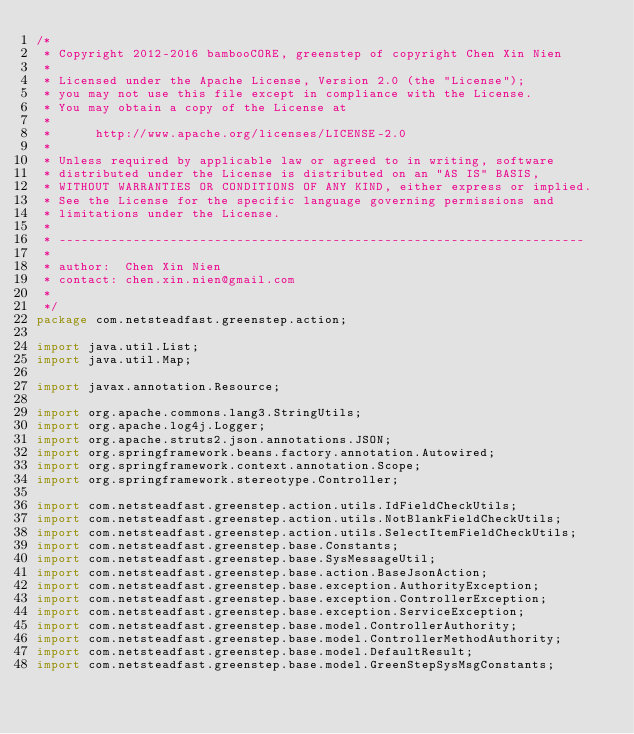<code> <loc_0><loc_0><loc_500><loc_500><_Java_>/* 
 * Copyright 2012-2016 bambooCORE, greenstep of copyright Chen Xin Nien
 * 
 * Licensed under the Apache License, Version 2.0 (the "License");
 * you may not use this file except in compliance with the License.
 * You may obtain a copy of the License at
 * 
 *      http://www.apache.org/licenses/LICENSE-2.0
 * 
 * Unless required by applicable law or agreed to in writing, software
 * distributed under the License is distributed on an "AS IS" BASIS,
 * WITHOUT WARRANTIES OR CONDITIONS OF ANY KIND, either express or implied.
 * See the License for the specific language governing permissions and
 * limitations under the License.
 * 
 * -----------------------------------------------------------------------
 * 
 * author: 	Chen Xin Nien
 * contact: chen.xin.nien@gmail.com
 * 
 */
package com.netsteadfast.greenstep.action;

import java.util.List;
import java.util.Map;

import javax.annotation.Resource;

import org.apache.commons.lang3.StringUtils;
import org.apache.log4j.Logger;
import org.apache.struts2.json.annotations.JSON;
import org.springframework.beans.factory.annotation.Autowired;
import org.springframework.context.annotation.Scope;
import org.springframework.stereotype.Controller;

import com.netsteadfast.greenstep.action.utils.IdFieldCheckUtils;
import com.netsteadfast.greenstep.action.utils.NotBlankFieldCheckUtils;
import com.netsteadfast.greenstep.action.utils.SelectItemFieldCheckUtils;
import com.netsteadfast.greenstep.base.Constants;
import com.netsteadfast.greenstep.base.SysMessageUtil;
import com.netsteadfast.greenstep.base.action.BaseJsonAction;
import com.netsteadfast.greenstep.base.exception.AuthorityException;
import com.netsteadfast.greenstep.base.exception.ControllerException;
import com.netsteadfast.greenstep.base.exception.ServiceException;
import com.netsteadfast.greenstep.base.model.ControllerAuthority;
import com.netsteadfast.greenstep.base.model.ControllerMethodAuthority;
import com.netsteadfast.greenstep.base.model.DefaultResult;
import com.netsteadfast.greenstep.base.model.GreenStepSysMsgConstants;</code> 